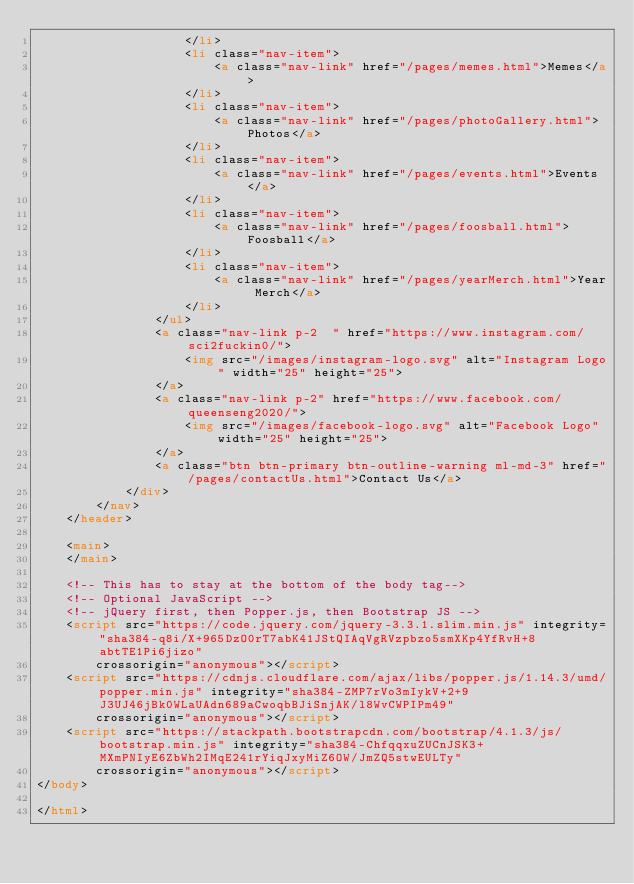Convert code to text. <code><loc_0><loc_0><loc_500><loc_500><_HTML_>                    </li>
                    <li class="nav-item">
                        <a class="nav-link" href="/pages/memes.html">Memes</a>
                    </li>
                    <li class="nav-item">
                        <a class="nav-link" href="/pages/photoGallery.html">Photos</a>
                    </li>
                    <li class="nav-item">
                        <a class="nav-link" href="/pages/events.html">Events</a>
                    </li>
                    <li class="nav-item">
                        <a class="nav-link" href="/pages/foosball.html">Foosball</a>
                    </li>
                    <li class="nav-item">
                        <a class="nav-link" href="/pages/yearMerch.html">Year Merch</a>
                    </li>
                </ul>
                <a class="nav-link p-2  " href="https://www.instagram.com/sci2fuckin0/">
                    <img src="/images/instagram-logo.svg" alt="Instagram Logo" width="25" height="25">
                </a>
                <a class="nav-link p-2" href="https://www.facebook.com/queenseng2020/">
                    <img src="/images/facebook-logo.svg" alt="Facebook Logo" width="25" height="25">
                </a>
                <a class="btn btn-primary btn-outline-warning ml-md-3" href="/pages/contactUs.html">Contact Us</a>
            </div>
        </nav>
    </header>

    <main>
    </main>

    <!-- This has to stay at the bottom of the body tag-->
    <!-- Optional JavaScript -->
    <!-- jQuery first, then Popper.js, then Bootstrap JS -->
    <script src="https://code.jquery.com/jquery-3.3.1.slim.min.js" integrity="sha384-q8i/X+965DzO0rT7abK41JStQIAqVgRVzpbzo5smXKp4YfRvH+8abtTE1Pi6jizo"
        crossorigin="anonymous"></script>
    <script src="https://cdnjs.cloudflare.com/ajax/libs/popper.js/1.14.3/umd/popper.min.js" integrity="sha384-ZMP7rVo3mIykV+2+9J3UJ46jBk0WLaUAdn689aCwoqbBJiSnjAK/l8WvCWPIPm49"
        crossorigin="anonymous"></script>
    <script src="https://stackpath.bootstrapcdn.com/bootstrap/4.1.3/js/bootstrap.min.js" integrity="sha384-ChfqqxuZUCnJSK3+MXmPNIyE6ZbWh2IMqE241rYiqJxyMiZ6OW/JmZQ5stwEULTy"
        crossorigin="anonymous"></script>
</body>

</html></code> 